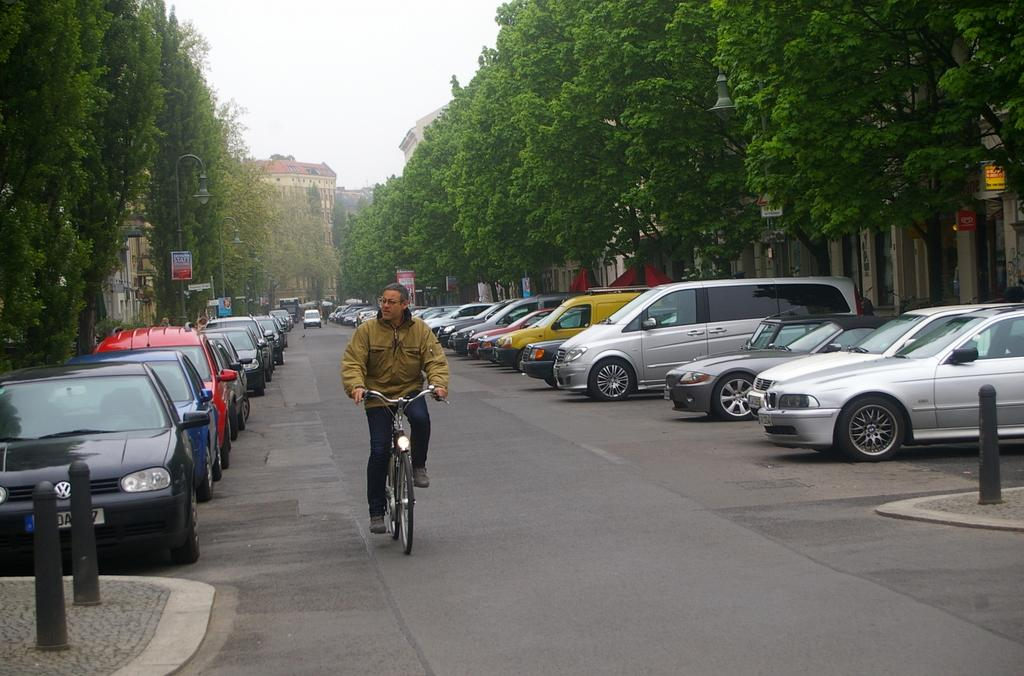What is visible at the top of the image? The sky is visible at the top of the image. What can be seen in the background of the image? There is a large building and trees in the background of the image. What is the man in the image doing? The man is riding a bicycle in the image. What type of vehicles are visible on the road in the image? Cars are visible on the road in the image, and some of them are parked. Can you see the man's toes in the image? There is no indication of the man's toes in the image, as he is wearing shoes while riding the bicycle. What type of meat is being grilled on the barbecue in the image? There is no barbecue or meat present in the image. 